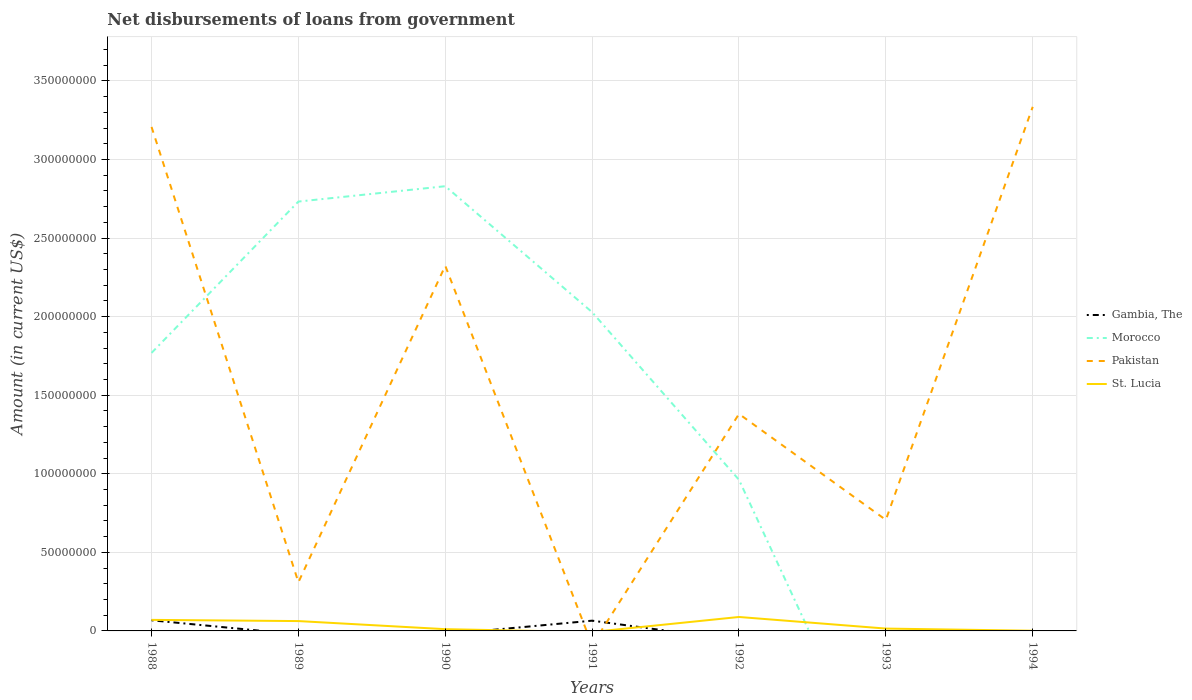How many different coloured lines are there?
Keep it short and to the point. 4. Does the line corresponding to Gambia, The intersect with the line corresponding to Morocco?
Provide a short and direct response. Yes. Across all years, what is the maximum amount of loan disbursed from government in Pakistan?
Provide a short and direct response. 0. What is the total amount of loan disbursed from government in Pakistan in the graph?
Give a very brief answer. 2.50e+08. What is the difference between the highest and the second highest amount of loan disbursed from government in Pakistan?
Give a very brief answer. 3.33e+08. Is the amount of loan disbursed from government in St. Lucia strictly greater than the amount of loan disbursed from government in Morocco over the years?
Keep it short and to the point. No. Are the values on the major ticks of Y-axis written in scientific E-notation?
Offer a very short reply. No. Does the graph contain any zero values?
Provide a short and direct response. Yes. Does the graph contain grids?
Your answer should be very brief. Yes. How are the legend labels stacked?
Offer a very short reply. Vertical. What is the title of the graph?
Offer a very short reply. Net disbursements of loans from government. What is the label or title of the Y-axis?
Make the answer very short. Amount (in current US$). What is the Amount (in current US$) of Gambia, The in 1988?
Ensure brevity in your answer.  6.77e+06. What is the Amount (in current US$) of Morocco in 1988?
Offer a very short reply. 1.77e+08. What is the Amount (in current US$) in Pakistan in 1988?
Your response must be concise. 3.21e+08. What is the Amount (in current US$) in St. Lucia in 1988?
Give a very brief answer. 7.03e+06. What is the Amount (in current US$) of Morocco in 1989?
Keep it short and to the point. 2.73e+08. What is the Amount (in current US$) of Pakistan in 1989?
Offer a very short reply. 3.10e+07. What is the Amount (in current US$) in St. Lucia in 1989?
Your answer should be compact. 6.26e+06. What is the Amount (in current US$) of Morocco in 1990?
Offer a very short reply. 2.83e+08. What is the Amount (in current US$) in Pakistan in 1990?
Your answer should be very brief. 2.32e+08. What is the Amount (in current US$) of St. Lucia in 1990?
Provide a short and direct response. 1.11e+06. What is the Amount (in current US$) of Gambia, The in 1991?
Offer a terse response. 6.52e+06. What is the Amount (in current US$) in Morocco in 1991?
Keep it short and to the point. 2.03e+08. What is the Amount (in current US$) in St. Lucia in 1991?
Your answer should be very brief. 0. What is the Amount (in current US$) in Gambia, The in 1992?
Your response must be concise. 0. What is the Amount (in current US$) in Morocco in 1992?
Make the answer very short. 9.61e+07. What is the Amount (in current US$) of Pakistan in 1992?
Keep it short and to the point. 1.38e+08. What is the Amount (in current US$) in St. Lucia in 1992?
Keep it short and to the point. 8.88e+06. What is the Amount (in current US$) in Gambia, The in 1993?
Give a very brief answer. 0. What is the Amount (in current US$) in Morocco in 1993?
Give a very brief answer. 0. What is the Amount (in current US$) of Pakistan in 1993?
Offer a very short reply. 7.07e+07. What is the Amount (in current US$) in St. Lucia in 1993?
Your answer should be compact. 1.49e+06. What is the Amount (in current US$) in Morocco in 1994?
Offer a terse response. 0. What is the Amount (in current US$) in Pakistan in 1994?
Ensure brevity in your answer.  3.33e+08. What is the Amount (in current US$) of St. Lucia in 1994?
Provide a succinct answer. 1.32e+05. Across all years, what is the maximum Amount (in current US$) of Gambia, The?
Your response must be concise. 6.77e+06. Across all years, what is the maximum Amount (in current US$) of Morocco?
Your response must be concise. 2.83e+08. Across all years, what is the maximum Amount (in current US$) in Pakistan?
Provide a succinct answer. 3.33e+08. Across all years, what is the maximum Amount (in current US$) in St. Lucia?
Keep it short and to the point. 8.88e+06. Across all years, what is the minimum Amount (in current US$) of Gambia, The?
Your answer should be compact. 0. Across all years, what is the minimum Amount (in current US$) in Morocco?
Your answer should be very brief. 0. Across all years, what is the minimum Amount (in current US$) in St. Lucia?
Provide a short and direct response. 0. What is the total Amount (in current US$) of Gambia, The in the graph?
Your response must be concise. 1.33e+07. What is the total Amount (in current US$) of Morocco in the graph?
Ensure brevity in your answer.  1.03e+09. What is the total Amount (in current US$) in Pakistan in the graph?
Give a very brief answer. 1.13e+09. What is the total Amount (in current US$) of St. Lucia in the graph?
Make the answer very short. 2.49e+07. What is the difference between the Amount (in current US$) of Morocco in 1988 and that in 1989?
Provide a short and direct response. -9.63e+07. What is the difference between the Amount (in current US$) of Pakistan in 1988 and that in 1989?
Your answer should be compact. 2.90e+08. What is the difference between the Amount (in current US$) in St. Lucia in 1988 and that in 1989?
Your answer should be very brief. 7.66e+05. What is the difference between the Amount (in current US$) in Morocco in 1988 and that in 1990?
Your answer should be compact. -1.06e+08. What is the difference between the Amount (in current US$) of Pakistan in 1988 and that in 1990?
Your answer should be compact. 8.84e+07. What is the difference between the Amount (in current US$) of St. Lucia in 1988 and that in 1990?
Provide a succinct answer. 5.92e+06. What is the difference between the Amount (in current US$) of Morocco in 1988 and that in 1991?
Provide a short and direct response. -2.59e+07. What is the difference between the Amount (in current US$) in Morocco in 1988 and that in 1992?
Your answer should be compact. 8.08e+07. What is the difference between the Amount (in current US$) in Pakistan in 1988 and that in 1992?
Your answer should be very brief. 1.83e+08. What is the difference between the Amount (in current US$) in St. Lucia in 1988 and that in 1992?
Give a very brief answer. -1.85e+06. What is the difference between the Amount (in current US$) in Pakistan in 1988 and that in 1993?
Your answer should be very brief. 2.50e+08. What is the difference between the Amount (in current US$) in St. Lucia in 1988 and that in 1993?
Provide a short and direct response. 5.54e+06. What is the difference between the Amount (in current US$) of Pakistan in 1988 and that in 1994?
Give a very brief answer. -1.28e+07. What is the difference between the Amount (in current US$) in St. Lucia in 1988 and that in 1994?
Your answer should be compact. 6.90e+06. What is the difference between the Amount (in current US$) of Morocco in 1989 and that in 1990?
Your answer should be compact. -9.76e+06. What is the difference between the Amount (in current US$) of Pakistan in 1989 and that in 1990?
Ensure brevity in your answer.  -2.01e+08. What is the difference between the Amount (in current US$) of St. Lucia in 1989 and that in 1990?
Provide a succinct answer. 5.15e+06. What is the difference between the Amount (in current US$) in Morocco in 1989 and that in 1991?
Provide a succinct answer. 7.04e+07. What is the difference between the Amount (in current US$) of Morocco in 1989 and that in 1992?
Offer a very short reply. 1.77e+08. What is the difference between the Amount (in current US$) of Pakistan in 1989 and that in 1992?
Your response must be concise. -1.07e+08. What is the difference between the Amount (in current US$) in St. Lucia in 1989 and that in 1992?
Ensure brevity in your answer.  -2.61e+06. What is the difference between the Amount (in current US$) in Pakistan in 1989 and that in 1993?
Your response must be concise. -3.97e+07. What is the difference between the Amount (in current US$) of St. Lucia in 1989 and that in 1993?
Your response must be concise. 4.77e+06. What is the difference between the Amount (in current US$) in Pakistan in 1989 and that in 1994?
Offer a very short reply. -3.03e+08. What is the difference between the Amount (in current US$) of St. Lucia in 1989 and that in 1994?
Make the answer very short. 6.13e+06. What is the difference between the Amount (in current US$) in Morocco in 1990 and that in 1991?
Provide a succinct answer. 8.02e+07. What is the difference between the Amount (in current US$) in Morocco in 1990 and that in 1992?
Offer a terse response. 1.87e+08. What is the difference between the Amount (in current US$) of Pakistan in 1990 and that in 1992?
Your answer should be very brief. 9.43e+07. What is the difference between the Amount (in current US$) in St. Lucia in 1990 and that in 1992?
Offer a very short reply. -7.76e+06. What is the difference between the Amount (in current US$) in Pakistan in 1990 and that in 1993?
Offer a terse response. 1.62e+08. What is the difference between the Amount (in current US$) in St. Lucia in 1990 and that in 1993?
Your answer should be compact. -3.82e+05. What is the difference between the Amount (in current US$) of Pakistan in 1990 and that in 1994?
Give a very brief answer. -1.01e+08. What is the difference between the Amount (in current US$) in St. Lucia in 1990 and that in 1994?
Ensure brevity in your answer.  9.79e+05. What is the difference between the Amount (in current US$) in Morocco in 1991 and that in 1992?
Make the answer very short. 1.07e+08. What is the difference between the Amount (in current US$) in Pakistan in 1992 and that in 1993?
Give a very brief answer. 6.74e+07. What is the difference between the Amount (in current US$) of St. Lucia in 1992 and that in 1993?
Offer a very short reply. 7.38e+06. What is the difference between the Amount (in current US$) in Pakistan in 1992 and that in 1994?
Offer a terse response. -1.95e+08. What is the difference between the Amount (in current US$) of St. Lucia in 1992 and that in 1994?
Provide a succinct answer. 8.74e+06. What is the difference between the Amount (in current US$) of Pakistan in 1993 and that in 1994?
Offer a terse response. -2.63e+08. What is the difference between the Amount (in current US$) in St. Lucia in 1993 and that in 1994?
Keep it short and to the point. 1.36e+06. What is the difference between the Amount (in current US$) of Gambia, The in 1988 and the Amount (in current US$) of Morocco in 1989?
Offer a terse response. -2.66e+08. What is the difference between the Amount (in current US$) of Gambia, The in 1988 and the Amount (in current US$) of Pakistan in 1989?
Offer a very short reply. -2.42e+07. What is the difference between the Amount (in current US$) of Gambia, The in 1988 and the Amount (in current US$) of St. Lucia in 1989?
Provide a succinct answer. 5.06e+05. What is the difference between the Amount (in current US$) in Morocco in 1988 and the Amount (in current US$) in Pakistan in 1989?
Give a very brief answer. 1.46e+08. What is the difference between the Amount (in current US$) of Morocco in 1988 and the Amount (in current US$) of St. Lucia in 1989?
Your response must be concise. 1.71e+08. What is the difference between the Amount (in current US$) of Pakistan in 1988 and the Amount (in current US$) of St. Lucia in 1989?
Offer a terse response. 3.14e+08. What is the difference between the Amount (in current US$) in Gambia, The in 1988 and the Amount (in current US$) in Morocco in 1990?
Your response must be concise. -2.76e+08. What is the difference between the Amount (in current US$) in Gambia, The in 1988 and the Amount (in current US$) in Pakistan in 1990?
Offer a very short reply. -2.26e+08. What is the difference between the Amount (in current US$) of Gambia, The in 1988 and the Amount (in current US$) of St. Lucia in 1990?
Offer a terse response. 5.66e+06. What is the difference between the Amount (in current US$) in Morocco in 1988 and the Amount (in current US$) in Pakistan in 1990?
Offer a terse response. -5.54e+07. What is the difference between the Amount (in current US$) of Morocco in 1988 and the Amount (in current US$) of St. Lucia in 1990?
Offer a terse response. 1.76e+08. What is the difference between the Amount (in current US$) in Pakistan in 1988 and the Amount (in current US$) in St. Lucia in 1990?
Ensure brevity in your answer.  3.20e+08. What is the difference between the Amount (in current US$) in Gambia, The in 1988 and the Amount (in current US$) in Morocco in 1991?
Your answer should be compact. -1.96e+08. What is the difference between the Amount (in current US$) of Gambia, The in 1988 and the Amount (in current US$) of Morocco in 1992?
Provide a succinct answer. -8.94e+07. What is the difference between the Amount (in current US$) in Gambia, The in 1988 and the Amount (in current US$) in Pakistan in 1992?
Your answer should be very brief. -1.31e+08. What is the difference between the Amount (in current US$) of Gambia, The in 1988 and the Amount (in current US$) of St. Lucia in 1992?
Ensure brevity in your answer.  -2.11e+06. What is the difference between the Amount (in current US$) in Morocco in 1988 and the Amount (in current US$) in Pakistan in 1992?
Provide a short and direct response. 3.88e+07. What is the difference between the Amount (in current US$) in Morocco in 1988 and the Amount (in current US$) in St. Lucia in 1992?
Provide a short and direct response. 1.68e+08. What is the difference between the Amount (in current US$) in Pakistan in 1988 and the Amount (in current US$) in St. Lucia in 1992?
Your answer should be very brief. 3.12e+08. What is the difference between the Amount (in current US$) in Gambia, The in 1988 and the Amount (in current US$) in Pakistan in 1993?
Make the answer very short. -6.39e+07. What is the difference between the Amount (in current US$) of Gambia, The in 1988 and the Amount (in current US$) of St. Lucia in 1993?
Offer a very short reply. 5.28e+06. What is the difference between the Amount (in current US$) of Morocco in 1988 and the Amount (in current US$) of Pakistan in 1993?
Provide a short and direct response. 1.06e+08. What is the difference between the Amount (in current US$) in Morocco in 1988 and the Amount (in current US$) in St. Lucia in 1993?
Provide a short and direct response. 1.75e+08. What is the difference between the Amount (in current US$) of Pakistan in 1988 and the Amount (in current US$) of St. Lucia in 1993?
Your answer should be very brief. 3.19e+08. What is the difference between the Amount (in current US$) of Gambia, The in 1988 and the Amount (in current US$) of Pakistan in 1994?
Offer a very short reply. -3.27e+08. What is the difference between the Amount (in current US$) of Gambia, The in 1988 and the Amount (in current US$) of St. Lucia in 1994?
Make the answer very short. 6.64e+06. What is the difference between the Amount (in current US$) in Morocco in 1988 and the Amount (in current US$) in Pakistan in 1994?
Give a very brief answer. -1.57e+08. What is the difference between the Amount (in current US$) of Morocco in 1988 and the Amount (in current US$) of St. Lucia in 1994?
Your answer should be compact. 1.77e+08. What is the difference between the Amount (in current US$) of Pakistan in 1988 and the Amount (in current US$) of St. Lucia in 1994?
Offer a very short reply. 3.21e+08. What is the difference between the Amount (in current US$) of Morocco in 1989 and the Amount (in current US$) of Pakistan in 1990?
Keep it short and to the point. 4.09e+07. What is the difference between the Amount (in current US$) in Morocco in 1989 and the Amount (in current US$) in St. Lucia in 1990?
Offer a terse response. 2.72e+08. What is the difference between the Amount (in current US$) in Pakistan in 1989 and the Amount (in current US$) in St. Lucia in 1990?
Ensure brevity in your answer.  2.99e+07. What is the difference between the Amount (in current US$) of Morocco in 1989 and the Amount (in current US$) of Pakistan in 1992?
Give a very brief answer. 1.35e+08. What is the difference between the Amount (in current US$) of Morocco in 1989 and the Amount (in current US$) of St. Lucia in 1992?
Give a very brief answer. 2.64e+08. What is the difference between the Amount (in current US$) in Pakistan in 1989 and the Amount (in current US$) in St. Lucia in 1992?
Give a very brief answer. 2.21e+07. What is the difference between the Amount (in current US$) in Morocco in 1989 and the Amount (in current US$) in Pakistan in 1993?
Make the answer very short. 2.03e+08. What is the difference between the Amount (in current US$) of Morocco in 1989 and the Amount (in current US$) of St. Lucia in 1993?
Provide a short and direct response. 2.72e+08. What is the difference between the Amount (in current US$) in Pakistan in 1989 and the Amount (in current US$) in St. Lucia in 1993?
Provide a short and direct response. 2.95e+07. What is the difference between the Amount (in current US$) of Morocco in 1989 and the Amount (in current US$) of Pakistan in 1994?
Your answer should be compact. -6.03e+07. What is the difference between the Amount (in current US$) in Morocco in 1989 and the Amount (in current US$) in St. Lucia in 1994?
Ensure brevity in your answer.  2.73e+08. What is the difference between the Amount (in current US$) of Pakistan in 1989 and the Amount (in current US$) of St. Lucia in 1994?
Give a very brief answer. 3.08e+07. What is the difference between the Amount (in current US$) of Morocco in 1990 and the Amount (in current US$) of Pakistan in 1992?
Make the answer very short. 1.45e+08. What is the difference between the Amount (in current US$) of Morocco in 1990 and the Amount (in current US$) of St. Lucia in 1992?
Your response must be concise. 2.74e+08. What is the difference between the Amount (in current US$) in Pakistan in 1990 and the Amount (in current US$) in St. Lucia in 1992?
Ensure brevity in your answer.  2.23e+08. What is the difference between the Amount (in current US$) of Morocco in 1990 and the Amount (in current US$) of Pakistan in 1993?
Your answer should be very brief. 2.12e+08. What is the difference between the Amount (in current US$) in Morocco in 1990 and the Amount (in current US$) in St. Lucia in 1993?
Keep it short and to the point. 2.81e+08. What is the difference between the Amount (in current US$) in Pakistan in 1990 and the Amount (in current US$) in St. Lucia in 1993?
Your response must be concise. 2.31e+08. What is the difference between the Amount (in current US$) in Morocco in 1990 and the Amount (in current US$) in Pakistan in 1994?
Your answer should be compact. -5.05e+07. What is the difference between the Amount (in current US$) of Morocco in 1990 and the Amount (in current US$) of St. Lucia in 1994?
Your response must be concise. 2.83e+08. What is the difference between the Amount (in current US$) of Pakistan in 1990 and the Amount (in current US$) of St. Lucia in 1994?
Provide a short and direct response. 2.32e+08. What is the difference between the Amount (in current US$) of Gambia, The in 1991 and the Amount (in current US$) of Morocco in 1992?
Your answer should be very brief. -8.96e+07. What is the difference between the Amount (in current US$) in Gambia, The in 1991 and the Amount (in current US$) in Pakistan in 1992?
Keep it short and to the point. -1.32e+08. What is the difference between the Amount (in current US$) of Gambia, The in 1991 and the Amount (in current US$) of St. Lucia in 1992?
Your response must be concise. -2.36e+06. What is the difference between the Amount (in current US$) in Morocco in 1991 and the Amount (in current US$) in Pakistan in 1992?
Offer a very short reply. 6.47e+07. What is the difference between the Amount (in current US$) in Morocco in 1991 and the Amount (in current US$) in St. Lucia in 1992?
Provide a short and direct response. 1.94e+08. What is the difference between the Amount (in current US$) in Gambia, The in 1991 and the Amount (in current US$) in Pakistan in 1993?
Your answer should be compact. -6.41e+07. What is the difference between the Amount (in current US$) in Gambia, The in 1991 and the Amount (in current US$) in St. Lucia in 1993?
Keep it short and to the point. 5.03e+06. What is the difference between the Amount (in current US$) in Morocco in 1991 and the Amount (in current US$) in Pakistan in 1993?
Ensure brevity in your answer.  1.32e+08. What is the difference between the Amount (in current US$) of Morocco in 1991 and the Amount (in current US$) of St. Lucia in 1993?
Your response must be concise. 2.01e+08. What is the difference between the Amount (in current US$) of Gambia, The in 1991 and the Amount (in current US$) of Pakistan in 1994?
Make the answer very short. -3.27e+08. What is the difference between the Amount (in current US$) of Gambia, The in 1991 and the Amount (in current US$) of St. Lucia in 1994?
Offer a very short reply. 6.39e+06. What is the difference between the Amount (in current US$) of Morocco in 1991 and the Amount (in current US$) of Pakistan in 1994?
Your response must be concise. -1.31e+08. What is the difference between the Amount (in current US$) in Morocco in 1991 and the Amount (in current US$) in St. Lucia in 1994?
Ensure brevity in your answer.  2.03e+08. What is the difference between the Amount (in current US$) in Morocco in 1992 and the Amount (in current US$) in Pakistan in 1993?
Offer a terse response. 2.55e+07. What is the difference between the Amount (in current US$) of Morocco in 1992 and the Amount (in current US$) of St. Lucia in 1993?
Give a very brief answer. 9.46e+07. What is the difference between the Amount (in current US$) of Pakistan in 1992 and the Amount (in current US$) of St. Lucia in 1993?
Ensure brevity in your answer.  1.37e+08. What is the difference between the Amount (in current US$) in Morocco in 1992 and the Amount (in current US$) in Pakistan in 1994?
Your answer should be compact. -2.37e+08. What is the difference between the Amount (in current US$) in Morocco in 1992 and the Amount (in current US$) in St. Lucia in 1994?
Keep it short and to the point. 9.60e+07. What is the difference between the Amount (in current US$) in Pakistan in 1992 and the Amount (in current US$) in St. Lucia in 1994?
Ensure brevity in your answer.  1.38e+08. What is the difference between the Amount (in current US$) in Pakistan in 1993 and the Amount (in current US$) in St. Lucia in 1994?
Ensure brevity in your answer.  7.05e+07. What is the average Amount (in current US$) of Gambia, The per year?
Make the answer very short. 1.90e+06. What is the average Amount (in current US$) in Morocco per year?
Offer a very short reply. 1.47e+08. What is the average Amount (in current US$) of Pakistan per year?
Your answer should be very brief. 1.61e+08. What is the average Amount (in current US$) in St. Lucia per year?
Make the answer very short. 3.56e+06. In the year 1988, what is the difference between the Amount (in current US$) in Gambia, The and Amount (in current US$) in Morocco?
Give a very brief answer. -1.70e+08. In the year 1988, what is the difference between the Amount (in current US$) in Gambia, The and Amount (in current US$) in Pakistan?
Your answer should be compact. -3.14e+08. In the year 1988, what is the difference between the Amount (in current US$) of Gambia, The and Amount (in current US$) of St. Lucia?
Your answer should be compact. -2.60e+05. In the year 1988, what is the difference between the Amount (in current US$) of Morocco and Amount (in current US$) of Pakistan?
Give a very brief answer. -1.44e+08. In the year 1988, what is the difference between the Amount (in current US$) of Morocco and Amount (in current US$) of St. Lucia?
Offer a very short reply. 1.70e+08. In the year 1988, what is the difference between the Amount (in current US$) of Pakistan and Amount (in current US$) of St. Lucia?
Your answer should be very brief. 3.14e+08. In the year 1989, what is the difference between the Amount (in current US$) of Morocco and Amount (in current US$) of Pakistan?
Provide a short and direct response. 2.42e+08. In the year 1989, what is the difference between the Amount (in current US$) of Morocco and Amount (in current US$) of St. Lucia?
Provide a succinct answer. 2.67e+08. In the year 1989, what is the difference between the Amount (in current US$) of Pakistan and Amount (in current US$) of St. Lucia?
Ensure brevity in your answer.  2.47e+07. In the year 1990, what is the difference between the Amount (in current US$) in Morocco and Amount (in current US$) in Pakistan?
Your answer should be compact. 5.06e+07. In the year 1990, what is the difference between the Amount (in current US$) of Morocco and Amount (in current US$) of St. Lucia?
Make the answer very short. 2.82e+08. In the year 1990, what is the difference between the Amount (in current US$) in Pakistan and Amount (in current US$) in St. Lucia?
Ensure brevity in your answer.  2.31e+08. In the year 1991, what is the difference between the Amount (in current US$) in Gambia, The and Amount (in current US$) in Morocco?
Ensure brevity in your answer.  -1.96e+08. In the year 1992, what is the difference between the Amount (in current US$) in Morocco and Amount (in current US$) in Pakistan?
Provide a succinct answer. -4.19e+07. In the year 1992, what is the difference between the Amount (in current US$) of Morocco and Amount (in current US$) of St. Lucia?
Your answer should be very brief. 8.73e+07. In the year 1992, what is the difference between the Amount (in current US$) in Pakistan and Amount (in current US$) in St. Lucia?
Offer a terse response. 1.29e+08. In the year 1993, what is the difference between the Amount (in current US$) in Pakistan and Amount (in current US$) in St. Lucia?
Ensure brevity in your answer.  6.92e+07. In the year 1994, what is the difference between the Amount (in current US$) of Pakistan and Amount (in current US$) of St. Lucia?
Provide a succinct answer. 3.33e+08. What is the ratio of the Amount (in current US$) of Morocco in 1988 to that in 1989?
Make the answer very short. 0.65. What is the ratio of the Amount (in current US$) of Pakistan in 1988 to that in 1989?
Offer a terse response. 10.35. What is the ratio of the Amount (in current US$) of St. Lucia in 1988 to that in 1989?
Provide a short and direct response. 1.12. What is the ratio of the Amount (in current US$) in Morocco in 1988 to that in 1990?
Your response must be concise. 0.63. What is the ratio of the Amount (in current US$) of Pakistan in 1988 to that in 1990?
Offer a very short reply. 1.38. What is the ratio of the Amount (in current US$) in St. Lucia in 1988 to that in 1990?
Make the answer very short. 6.33. What is the ratio of the Amount (in current US$) in Gambia, The in 1988 to that in 1991?
Provide a succinct answer. 1.04. What is the ratio of the Amount (in current US$) in Morocco in 1988 to that in 1991?
Offer a terse response. 0.87. What is the ratio of the Amount (in current US$) of Morocco in 1988 to that in 1992?
Offer a terse response. 1.84. What is the ratio of the Amount (in current US$) in Pakistan in 1988 to that in 1992?
Offer a very short reply. 2.32. What is the ratio of the Amount (in current US$) in St. Lucia in 1988 to that in 1992?
Give a very brief answer. 0.79. What is the ratio of the Amount (in current US$) in Pakistan in 1988 to that in 1993?
Ensure brevity in your answer.  4.54. What is the ratio of the Amount (in current US$) of St. Lucia in 1988 to that in 1993?
Your answer should be very brief. 4.71. What is the ratio of the Amount (in current US$) in Pakistan in 1988 to that in 1994?
Provide a succinct answer. 0.96. What is the ratio of the Amount (in current US$) of St. Lucia in 1988 to that in 1994?
Ensure brevity in your answer.  53.25. What is the ratio of the Amount (in current US$) in Morocco in 1989 to that in 1990?
Give a very brief answer. 0.97. What is the ratio of the Amount (in current US$) in Pakistan in 1989 to that in 1990?
Keep it short and to the point. 0.13. What is the ratio of the Amount (in current US$) in St. Lucia in 1989 to that in 1990?
Your response must be concise. 5.64. What is the ratio of the Amount (in current US$) in Morocco in 1989 to that in 1991?
Your answer should be compact. 1.35. What is the ratio of the Amount (in current US$) in Morocco in 1989 to that in 1992?
Provide a short and direct response. 2.84. What is the ratio of the Amount (in current US$) of Pakistan in 1989 to that in 1992?
Make the answer very short. 0.22. What is the ratio of the Amount (in current US$) of St. Lucia in 1989 to that in 1992?
Provide a short and direct response. 0.71. What is the ratio of the Amount (in current US$) of Pakistan in 1989 to that in 1993?
Ensure brevity in your answer.  0.44. What is the ratio of the Amount (in current US$) of St. Lucia in 1989 to that in 1993?
Your response must be concise. 4.19. What is the ratio of the Amount (in current US$) of Pakistan in 1989 to that in 1994?
Your answer should be very brief. 0.09. What is the ratio of the Amount (in current US$) of St. Lucia in 1989 to that in 1994?
Give a very brief answer. 47.45. What is the ratio of the Amount (in current US$) of Morocco in 1990 to that in 1991?
Provide a short and direct response. 1.4. What is the ratio of the Amount (in current US$) of Morocco in 1990 to that in 1992?
Provide a short and direct response. 2.94. What is the ratio of the Amount (in current US$) in Pakistan in 1990 to that in 1992?
Your response must be concise. 1.68. What is the ratio of the Amount (in current US$) of St. Lucia in 1990 to that in 1992?
Your response must be concise. 0.13. What is the ratio of the Amount (in current US$) of Pakistan in 1990 to that in 1993?
Keep it short and to the point. 3.29. What is the ratio of the Amount (in current US$) in St. Lucia in 1990 to that in 1993?
Provide a short and direct response. 0.74. What is the ratio of the Amount (in current US$) of Pakistan in 1990 to that in 1994?
Give a very brief answer. 0.7. What is the ratio of the Amount (in current US$) in St. Lucia in 1990 to that in 1994?
Provide a short and direct response. 8.42. What is the ratio of the Amount (in current US$) of Morocco in 1991 to that in 1992?
Give a very brief answer. 2.11. What is the ratio of the Amount (in current US$) of Pakistan in 1992 to that in 1993?
Ensure brevity in your answer.  1.95. What is the ratio of the Amount (in current US$) in St. Lucia in 1992 to that in 1993?
Provide a succinct answer. 5.94. What is the ratio of the Amount (in current US$) of Pakistan in 1992 to that in 1994?
Make the answer very short. 0.41. What is the ratio of the Amount (in current US$) of St. Lucia in 1992 to that in 1994?
Make the answer very short. 67.23. What is the ratio of the Amount (in current US$) of Pakistan in 1993 to that in 1994?
Your answer should be compact. 0.21. What is the ratio of the Amount (in current US$) of St. Lucia in 1993 to that in 1994?
Your response must be concise. 11.31. What is the difference between the highest and the second highest Amount (in current US$) of Morocco?
Ensure brevity in your answer.  9.76e+06. What is the difference between the highest and the second highest Amount (in current US$) in Pakistan?
Keep it short and to the point. 1.28e+07. What is the difference between the highest and the second highest Amount (in current US$) in St. Lucia?
Offer a terse response. 1.85e+06. What is the difference between the highest and the lowest Amount (in current US$) of Gambia, The?
Make the answer very short. 6.77e+06. What is the difference between the highest and the lowest Amount (in current US$) of Morocco?
Keep it short and to the point. 2.83e+08. What is the difference between the highest and the lowest Amount (in current US$) in Pakistan?
Your answer should be compact. 3.33e+08. What is the difference between the highest and the lowest Amount (in current US$) in St. Lucia?
Make the answer very short. 8.88e+06. 